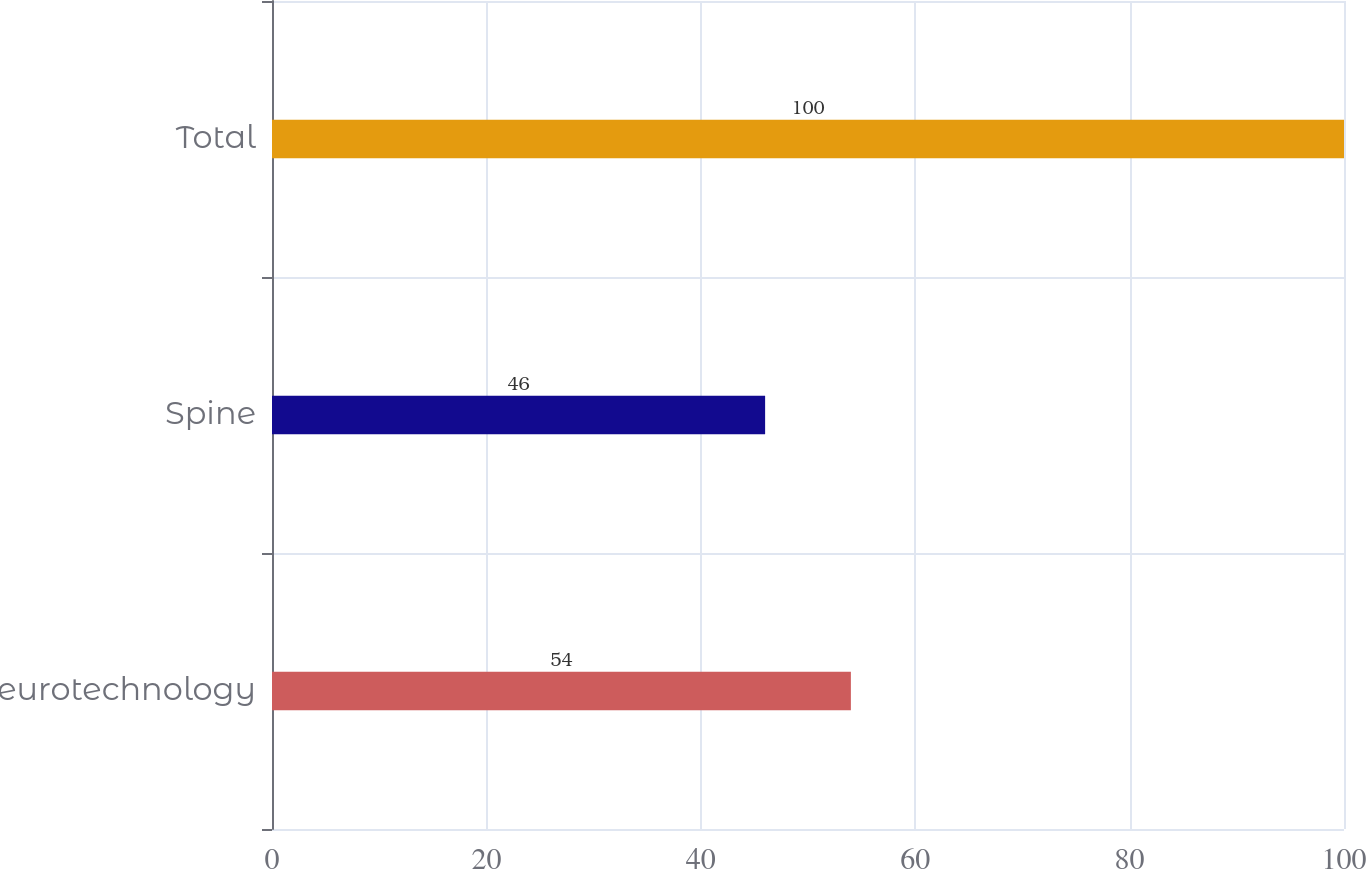Convert chart. <chart><loc_0><loc_0><loc_500><loc_500><bar_chart><fcel>Neurotechnology<fcel>Spine<fcel>Total<nl><fcel>54<fcel>46<fcel>100<nl></chart> 